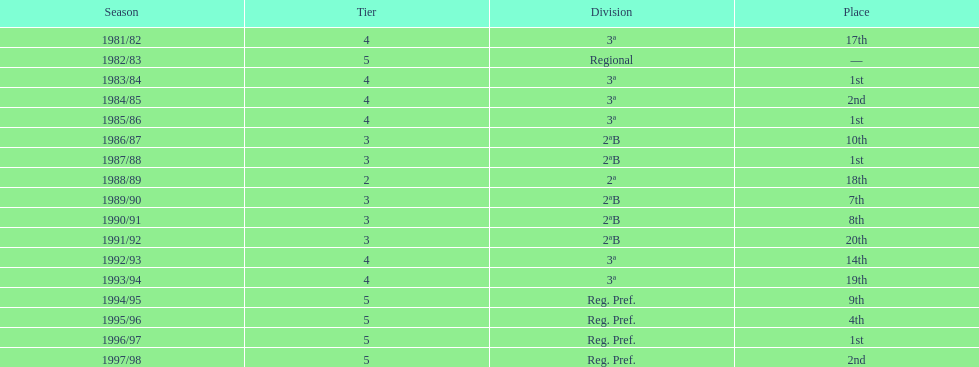Which season(s) earned first place? 1983/84, 1985/86, 1987/88, 1996/97. Could you help me parse every detail presented in this table? {'header': ['Season', 'Tier', 'Division', 'Place'], 'rows': [['1981/82', '4', '3ª', '17th'], ['1982/83', '5', 'Regional', '—'], ['1983/84', '4', '3ª', '1st'], ['1984/85', '4', '3ª', '2nd'], ['1985/86', '4', '3ª', '1st'], ['1986/87', '3', '2ªB', '10th'], ['1987/88', '3', '2ªB', '1st'], ['1988/89', '2', '2ª', '18th'], ['1989/90', '3', '2ªB', '7th'], ['1990/91', '3', '2ªB', '8th'], ['1991/92', '3', '2ªB', '20th'], ['1992/93', '4', '3ª', '14th'], ['1993/94', '4', '3ª', '19th'], ['1994/95', '5', 'Reg. Pref.', '9th'], ['1995/96', '5', 'Reg. Pref.', '4th'], ['1996/97', '5', 'Reg. Pref.', '1st'], ['1997/98', '5', 'Reg. Pref.', '2nd']]} 